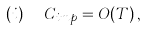Convert formula to latex. <formula><loc_0><loc_0><loc_500><loc_500>( i ) \ \ C _ { i m p } = O ( T ) \, ,</formula> 